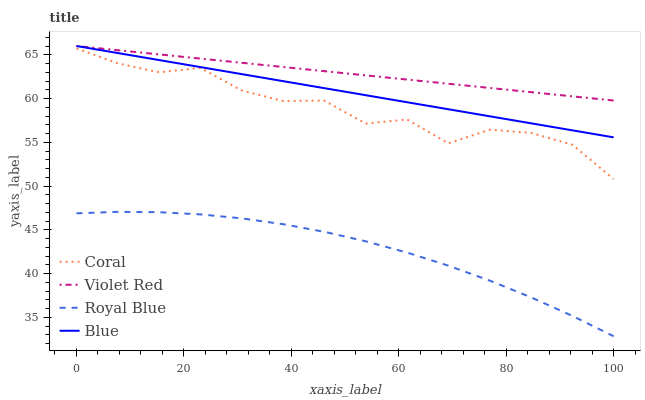Does Royal Blue have the minimum area under the curve?
Answer yes or no. Yes. Does Violet Red have the maximum area under the curve?
Answer yes or no. Yes. Does Coral have the minimum area under the curve?
Answer yes or no. No. Does Coral have the maximum area under the curve?
Answer yes or no. No. Is Blue the smoothest?
Answer yes or no. Yes. Is Coral the roughest?
Answer yes or no. Yes. Is Royal Blue the smoothest?
Answer yes or no. No. Is Royal Blue the roughest?
Answer yes or no. No. Does Royal Blue have the lowest value?
Answer yes or no. Yes. Does Coral have the lowest value?
Answer yes or no. No. Does Violet Red have the highest value?
Answer yes or no. Yes. Does Coral have the highest value?
Answer yes or no. No. Is Royal Blue less than Blue?
Answer yes or no. Yes. Is Blue greater than Royal Blue?
Answer yes or no. Yes. Does Blue intersect Violet Red?
Answer yes or no. Yes. Is Blue less than Violet Red?
Answer yes or no. No. Is Blue greater than Violet Red?
Answer yes or no. No. Does Royal Blue intersect Blue?
Answer yes or no. No. 